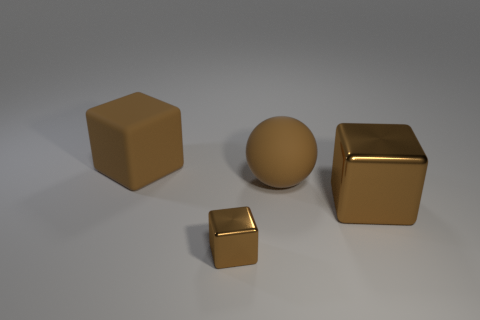Add 4 tiny brown metal cubes. How many objects exist? 8 Subtract all spheres. How many objects are left? 3 Add 2 big rubber balls. How many big rubber balls exist? 3 Subtract 0 yellow cylinders. How many objects are left? 4 Subtract all large yellow metal cylinders. Subtract all large spheres. How many objects are left? 3 Add 1 brown rubber things. How many brown rubber things are left? 3 